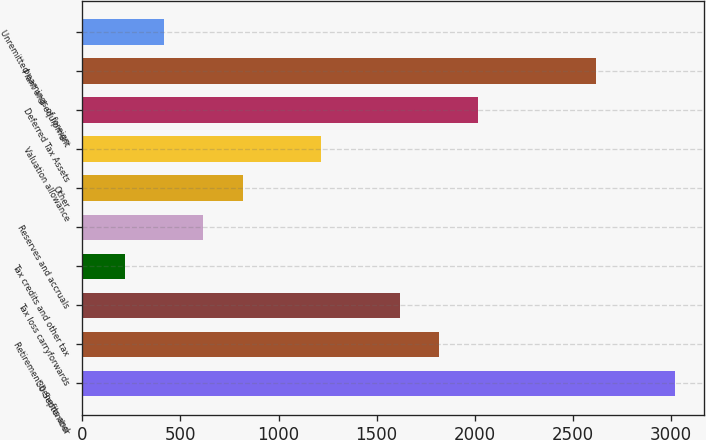<chart> <loc_0><loc_0><loc_500><loc_500><bar_chart><fcel>30 September<fcel>Retirement benefits and<fcel>Tax loss carryforwards<fcel>Tax credits and other tax<fcel>Reserves and accruals<fcel>Other<fcel>Valuation allowance<fcel>Deferred Tax Assets<fcel>Plant and equipment<fcel>Unremitted earnings of foreign<nl><fcel>3018.85<fcel>1817.83<fcel>1617.66<fcel>216.47<fcel>616.81<fcel>816.98<fcel>1217.32<fcel>2018<fcel>2618.51<fcel>416.64<nl></chart> 